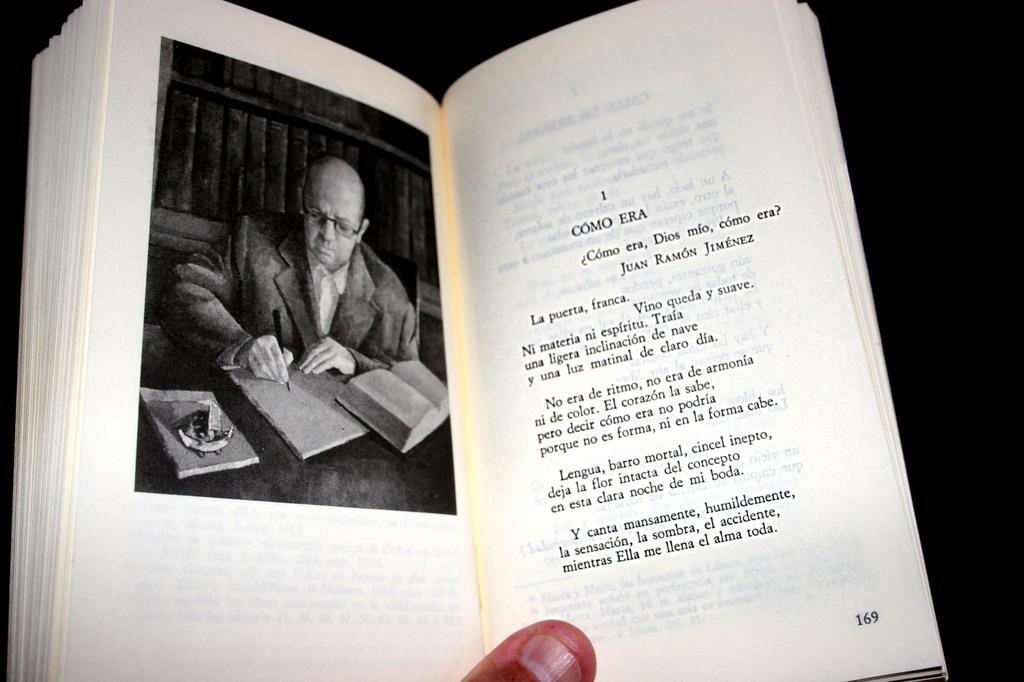Which page is this?
Provide a short and direct response. 169. What language is this in?
Provide a succinct answer. Spanish. 